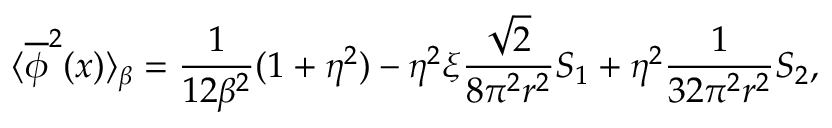<formula> <loc_0><loc_0><loc_500><loc_500>\langle \overline { \phi } ^ { 2 } ( x ) \rangle _ { \beta } = \frac { 1 } { 1 2 \beta ^ { 2 } } ( 1 + \eta ^ { 2 } ) - \eta ^ { 2 } \xi \frac { \sqrt { 2 } } { 8 \pi ^ { 2 } r ^ { 2 } } S _ { 1 } + \eta ^ { 2 } \frac { 1 } { 3 2 \pi ^ { 2 } r ^ { 2 } } S _ { 2 } ,</formula> 